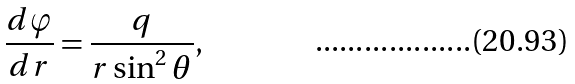<formula> <loc_0><loc_0><loc_500><loc_500>\frac { d \varphi } { d r } = \frac { q } { r \sin ^ { 2 } \theta } ,</formula> 